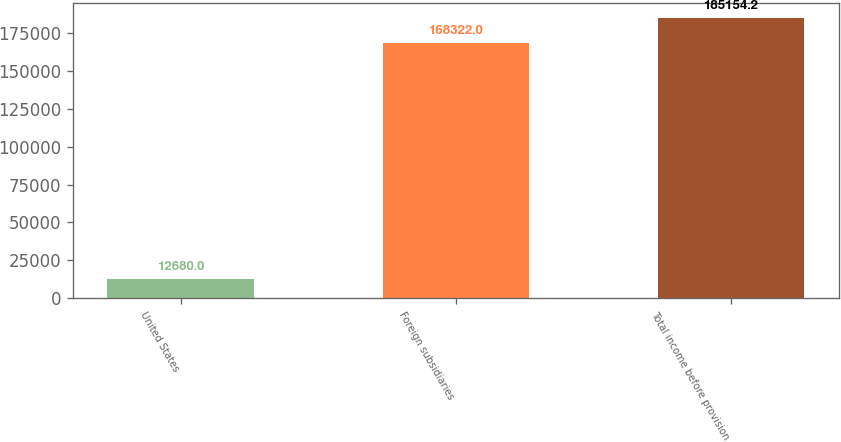Convert chart. <chart><loc_0><loc_0><loc_500><loc_500><bar_chart><fcel>United States<fcel>Foreign subsidiaries<fcel>Total income before provision<nl><fcel>12680<fcel>168322<fcel>185154<nl></chart> 